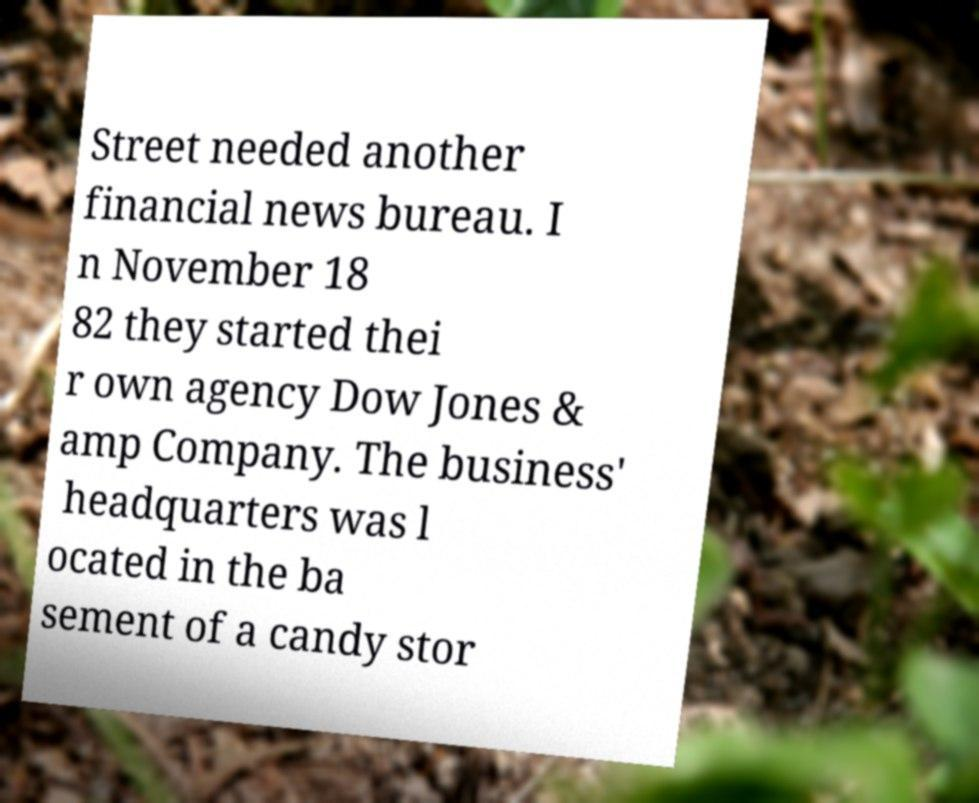Could you extract and type out the text from this image? Street needed another financial news bureau. I n November 18 82 they started thei r own agency Dow Jones & amp Company. The business' headquarters was l ocated in the ba sement of a candy stor 